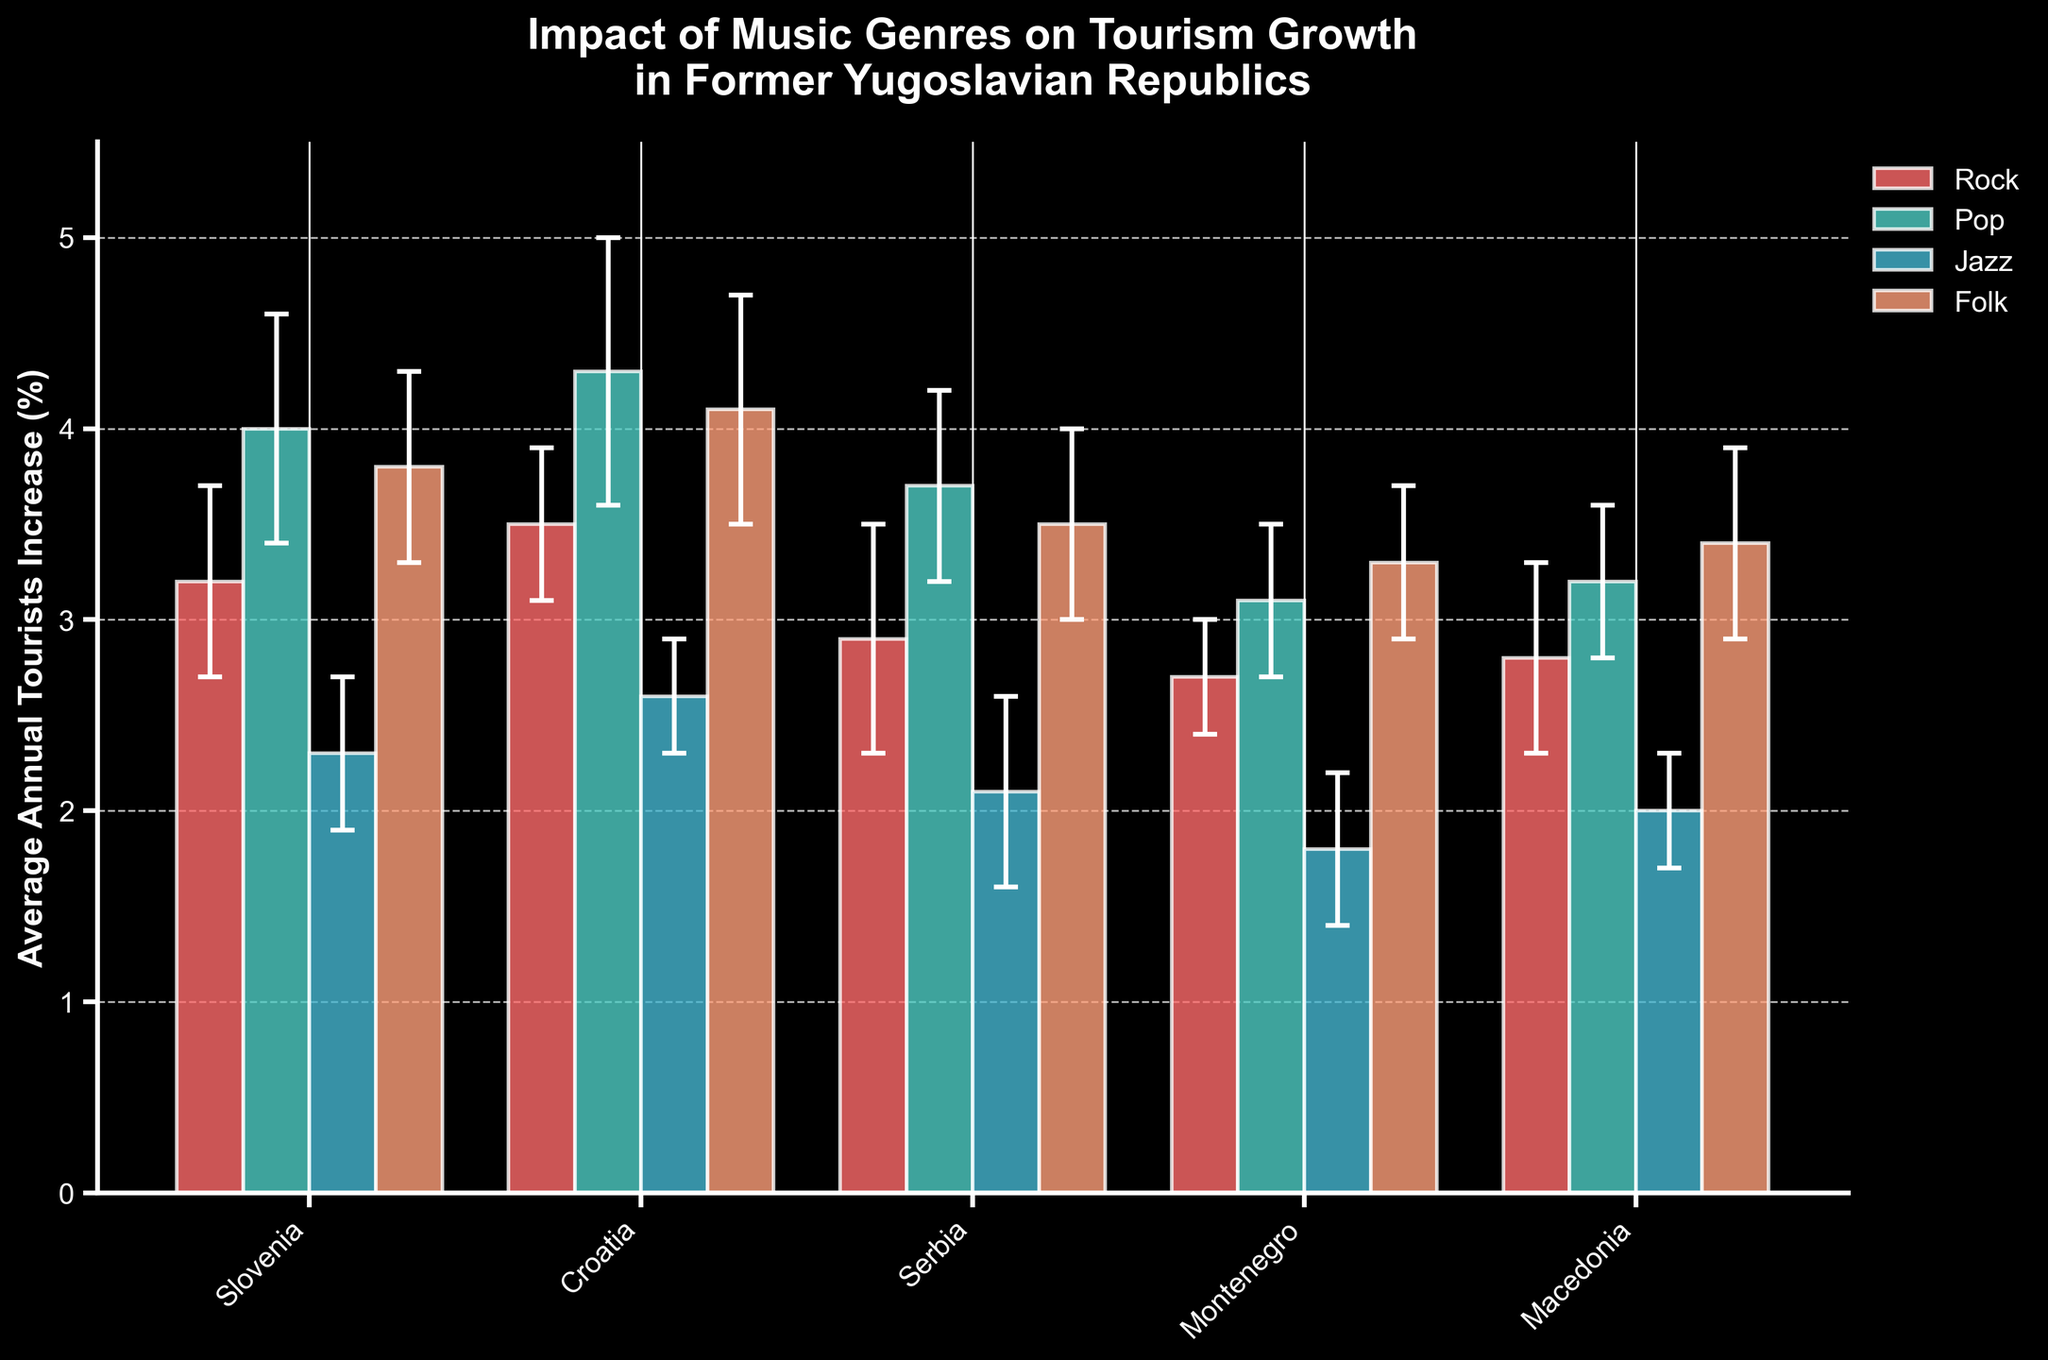What is the title of the chart? The title of the chart is located at the top and describes the content of the figure.
Answer: Impact of Music Genres on Tourism Growth in Former Yugoslavian Republics Which country shows the highest average annual tourists increase (%) for Pop music? Look for the highest bar in the Pop music section and identify the corresponding country from the x-axis labels.
Answer: Croatia How much higher is the average annual tourists increase (%) for Pop music in Serbia compared to Jazz music in the same country? Find the difference between the heights of the Pop music bar and the Jazz music bar for Serbia by subtracting Jazz value from Pop value.
Answer: 1.6% Which music genre has the highest variability in tourism growth in Croatia, as shown by the error bars? Identify the genre with the longest error bars for Croatia, which represent standard deviation.
Answer: Pop Compare the average annual tourists increase (%) for Rock music between Slovenia and Macedonia. Which country shows a higher increase? Check the Rock bars for both Slovenia and Macedonia, then compare their heights directly.
Answer: Slovenia In which country does Folk music result in a greater tourists increase compared to Jazz music? Compare the heights of Folk and Jazz bars across each country and note where Folk is higher than Jazz.
Answer: Slovenia, Croatia, Serbia, Montenegro, Macedonia Which music genre has the lowest average annual tourists increase (%) in Montenegro? Locate the shortest bar for Montenegro and identify its genre from the legend.
Answer: Jazz What is the difference in average annual tourists increase (%) between the highest and lowest genres in Slovenia? Identify the tallest and shortest bars in Slovenia, then subtract the lowest value from the highest value.
Answer: 1.7% Which genre shows a consistent trend in tourism growth across all countries, with relatively small error bars? Look for a genre where the error bars are short and the average annual tourists increase (%) is relatively consistent across all countries.
Answer: Folk 